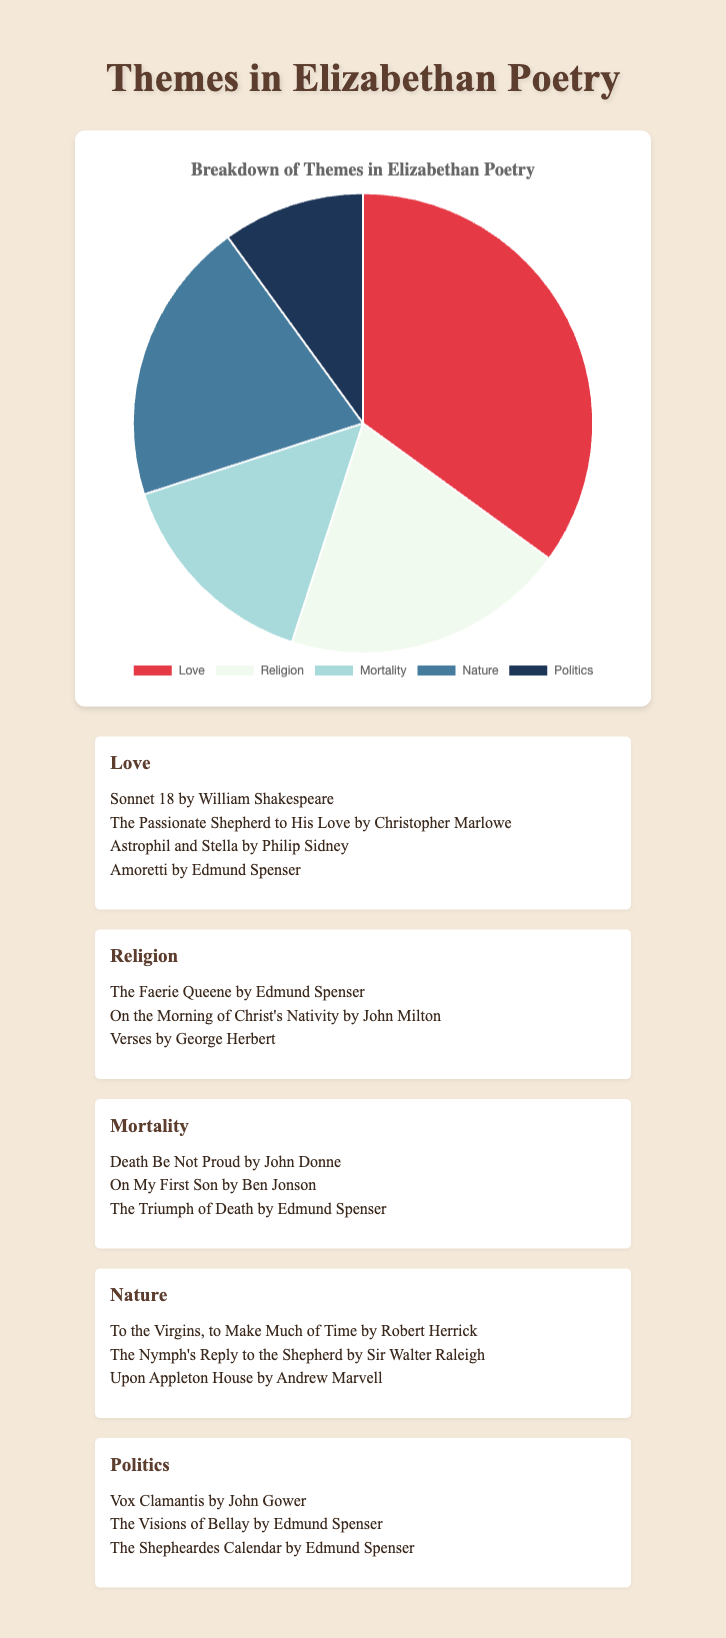What percentage of Elizabethan poetry themes are related to Love and Nature combined? To find the total percentage of topics related to both Love and Nature in Elizabethan poetry, sum the individual percentages of these two themes. The Love theme accounts for 35% and the Nature theme accounts for 20%. Adding these yields 35% + 20% = 55%.
Answer: 55% Which theme has the smallest representation in the pie chart? Review the percentages for each theme to identify the one with the smallest value. The themes are as follows: Love (35%), Religion (20%), Mortality (15%), Nature (20%), and Politics (10%). The theme with the lowest percentage is Politics at 10%.
Answer: Politics Is the percentage of poems related to Religion and Nature equal? Compare the percentages associated with the Religion and Nature themes provided in the chart. Both themes show a percentage of 20%, indicating they are indeed equal.
Answer: Yes What is the percentage difference between the themes of Mortality and Love? To determine the percentage difference between Mortality and Love, subtract the percentage of Mortality from Love. Love accounts for 35%, while Mortality accounts for 15%. Therefore, the difference is 35% - 15% = 20%.
Answer: 20% Which theme is represented by the largest slice on the pie chart, and what is the percentage? Identify the theme with the highest percentage from the provided data. The largest slice belongs to the Love theme, which is represented by 35% of the total.
Answer: Love, 35% How many themes have an equal representation in their percentage? Look for themes that share the same percentage in the data. The themes Religion and Nature both represent 20% of the pie chart, meaning two themes have equal representation.
Answer: Two If the percentage of Politics increased by 5%, what would be its new percentage? Add 5% to the current percentage of Politics. Currently, Politics is at 10%, and increasing by 5% gives 10% + 5% = 15%.
Answer: 15% What is the combined percentage of themes that are less than 20%? Identify themes with percentages under 20%: Mortality (15%) and Politics (10%). Add these percentages together: 15% + 10% = 25%.
Answer: 25% Which visual attribute would help identify themes with the same percentage in the pie chart? Themes with the same percentage can be identified by their slices having equal size in the pie chart. In this case, both Religion and Nature slices will be equal in size as they share the same percentage (20%).
Answer: Equal-sized slices By what factor is the percentage of the Love theme greater than the Politics theme? Divide the percentage of the Love theme by that of the Politics theme to find the factor. Love is 35%, and Politics is 10%, therefore 35% / 10% = 3.5.
Answer: 3.5 